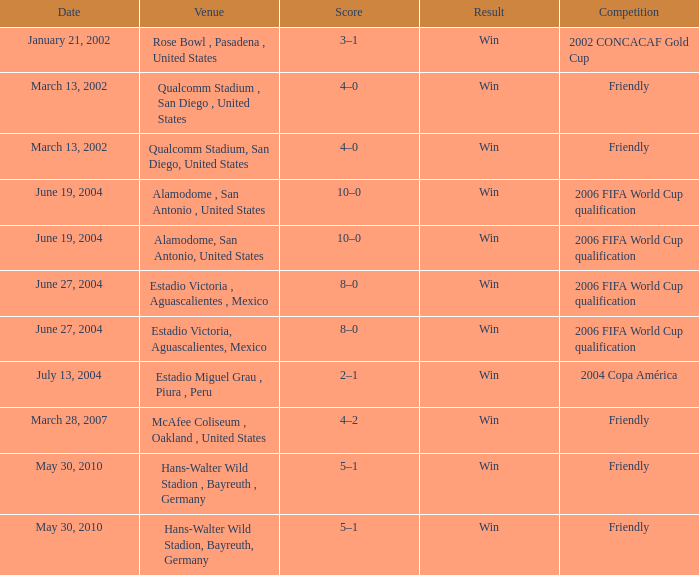What date has alamodome, san antonio, united states as the venue? June 19, 2004, June 19, 2004. 